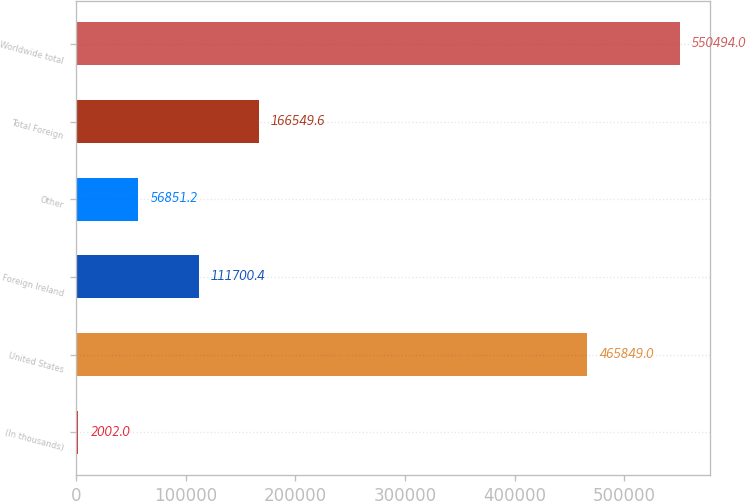Convert chart. <chart><loc_0><loc_0><loc_500><loc_500><bar_chart><fcel>(In thousands)<fcel>United States<fcel>Foreign Ireland<fcel>Other<fcel>Total Foreign<fcel>Worldwide total<nl><fcel>2002<fcel>465849<fcel>111700<fcel>56851.2<fcel>166550<fcel>550494<nl></chart> 